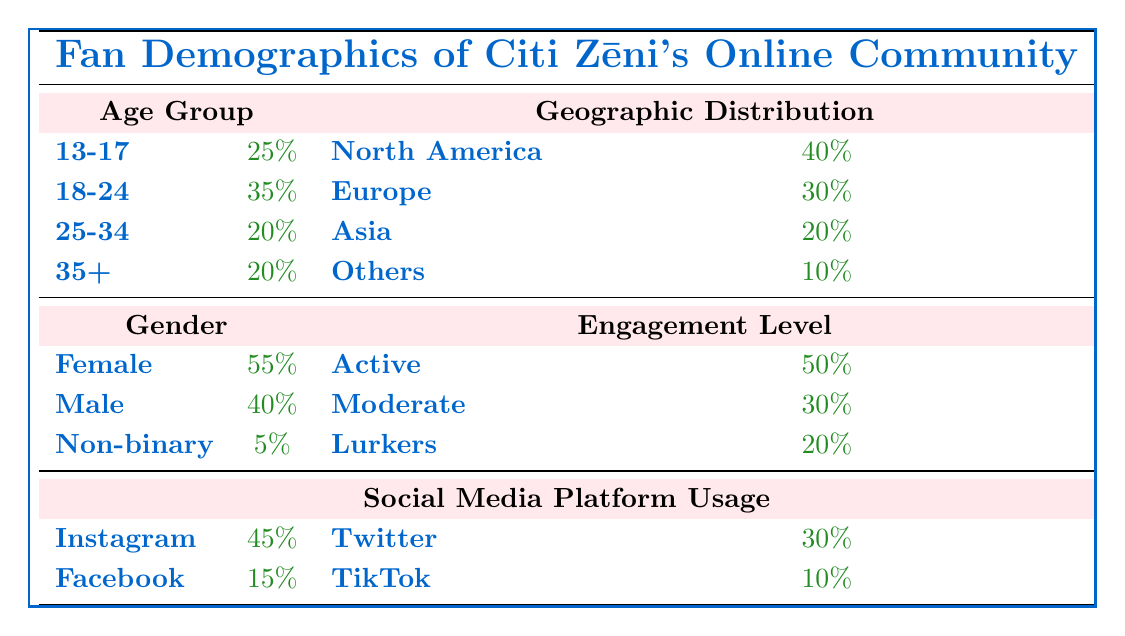What is the percentage of fans aged 18-24? The table shows the age groups with their corresponding percentages. The group for 18-24 specifically indicates a percentage of 35%.
Answer: 35% What percentage of the fans are male? Referring to the gender section of the table, the percentage listed for male fans is 40%.
Answer: 40% Which social media platform has the highest usage among fans? The social media platform section lists Instagram with a percentage of 45%, which is higher than the other platforms.
Answer: Instagram What is the percentage of fans that are either in the 25-34 age group or the 35+ age group? To find this, we add the percentages of the two age groups: 20% (25-34) + 20% (35+) = 40%.
Answer: 40% How many more fans identify as female compared to non-binary? The female percentage is 55% and the non-binary percentage is 5%. The difference is 55% - 5% = 50%.
Answer: 50% True or False: A larger percentage of fans are in the 13-17 age group than in the Asia region. The 13-17 age group has 25% while Asia has 20%. Since 25% is greater than 20%, the statement is true.
Answer: True What percentage of female fans are either active or moderate? The table shows that 50% of fans are active and 30% are moderate. The sum of these percentages is 50% + 30% = 80%.
Answer: 80% If 10% of the fans are lurkers, what is the total percentage of active and moderate fans combined? From the engagement level data, active fans are 50% and moderate fans are 30%. Adding these gives 50% + 30% = 80%.
Answer: 80% What proportion of the total fans are from North America compared to those from Europe? North America has 40% and Europe has 30%. To find the proportion, we calculate 40% / 30% = 1.33, or approximately 4:3.
Answer: 4:3 What is the total percentage of fans on platforms other than Instagram and Twitter? Instagram accounts for 45% and Twitter for 30%. To find the remaining percentage: 100% - (45% + 30%) = 25%.
Answer: 25% 